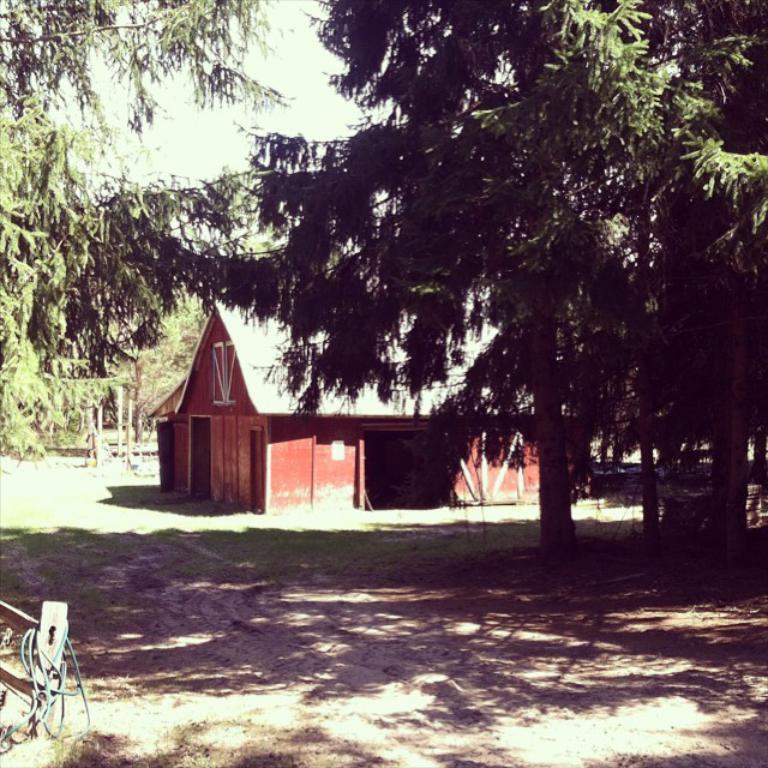What type of natural scenery can be seen in the background of the image? There are trees in the background of the image. What type of structure is visible in the background of the image? There is a hut in the background of the image. Can you describe the object on the left side of the image? Unfortunately, the facts provided do not give any information about the object on the left side of the image. How many flowers are present in the image? There is no mention of flowers in the provided facts, so we cannot determine their presence or quantity in the image. Can you describe the kittens playing in the hut in the image? There is no mention of kittens in the provided facts, so we cannot describe their presence or actions in the image. 